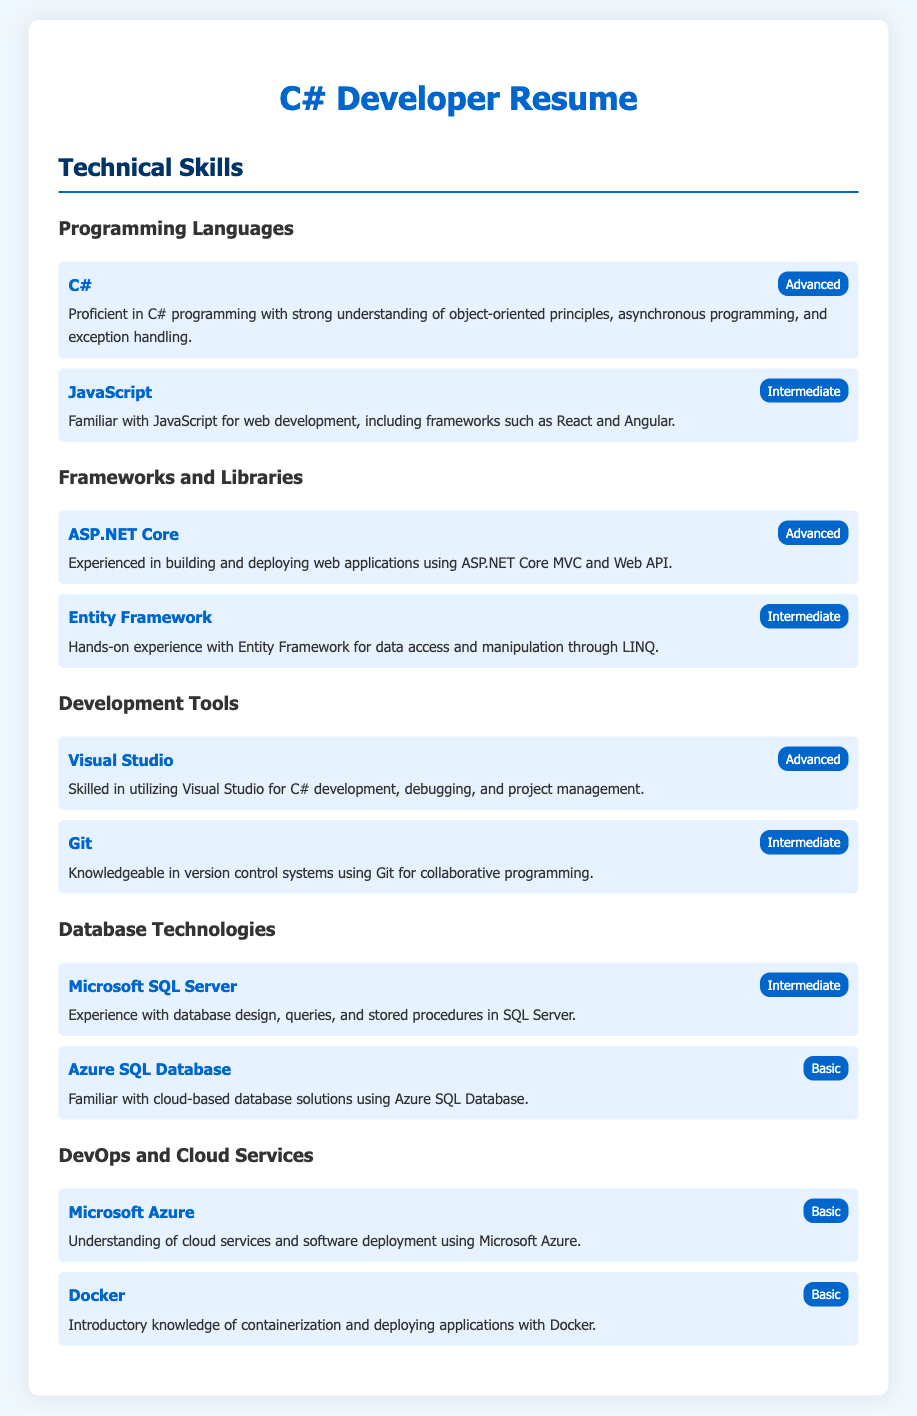What is the proficiency level of C#? The document states the proficiency level of C# as "Advanced."
Answer: Advanced Which programming language is intermediate proficiency? The document lists "JavaScript" as having an intermediate proficiency level in the Programming Languages section.
Answer: JavaScript What framework is mentioned as “experienced” in the document? "ASP.NET Core" is described as having experience in building and deploying web applications under Frameworks and Libraries.
Answer: ASP.NET Core How many database technologies are listed? There are two database technologies mentioned in the resume: "Microsoft SQL Server" and "Azure SQL Database."
Answer: 2 What type of tool is Visual Studio classified as? Visual Studio is classified under "Development Tools" and is indicated as "Advanced."
Answer: Development Tool Which cloud service proficiency is described as basic? "Microsoft Azure" and "Docker" are both mentioned as having basic proficiency levels in the DevOps and Cloud Services section.
Answer: Microsoft Azure What is the skill description provided for Entity Framework? The skill description for Entity Framework indicates "Hands-on experience with Entity Framework for data access and manipulation through LINQ."
Answer: Hands-on experience with Entity Framework for data access and manipulation through LINQ Which version control system is mentioned? The document mentions "Git" as a version control system used for collaborative programming.
Answer: Git What is the lowest proficiency level mentioned in the document? The lowest proficiency level mentioned is "Basic." This applies to both Azure SQL Database and Docker.
Answer: Basic 